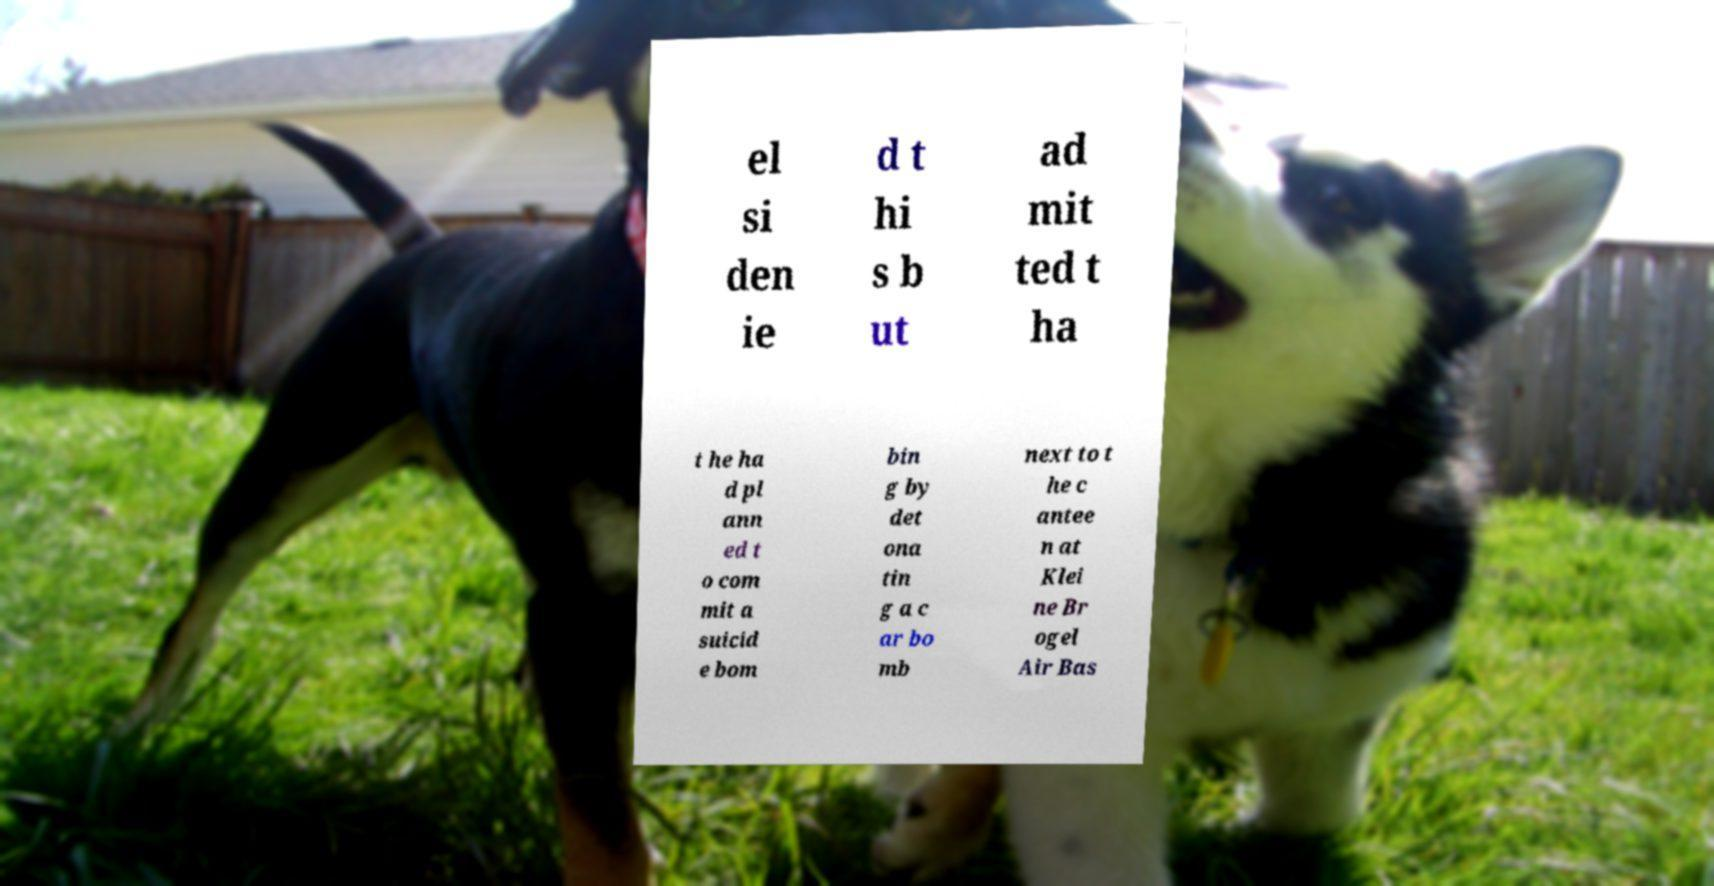Can you read and provide the text displayed in the image?This photo seems to have some interesting text. Can you extract and type it out for me? el si den ie d t hi s b ut ad mit ted t ha t he ha d pl ann ed t o com mit a suicid e bom bin g by det ona tin g a c ar bo mb next to t he c antee n at Klei ne Br ogel Air Bas 